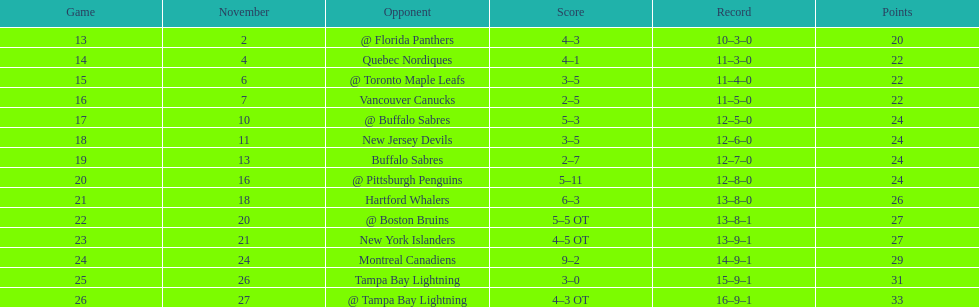What was the number of wins the philadelphia flyers had? 35. 